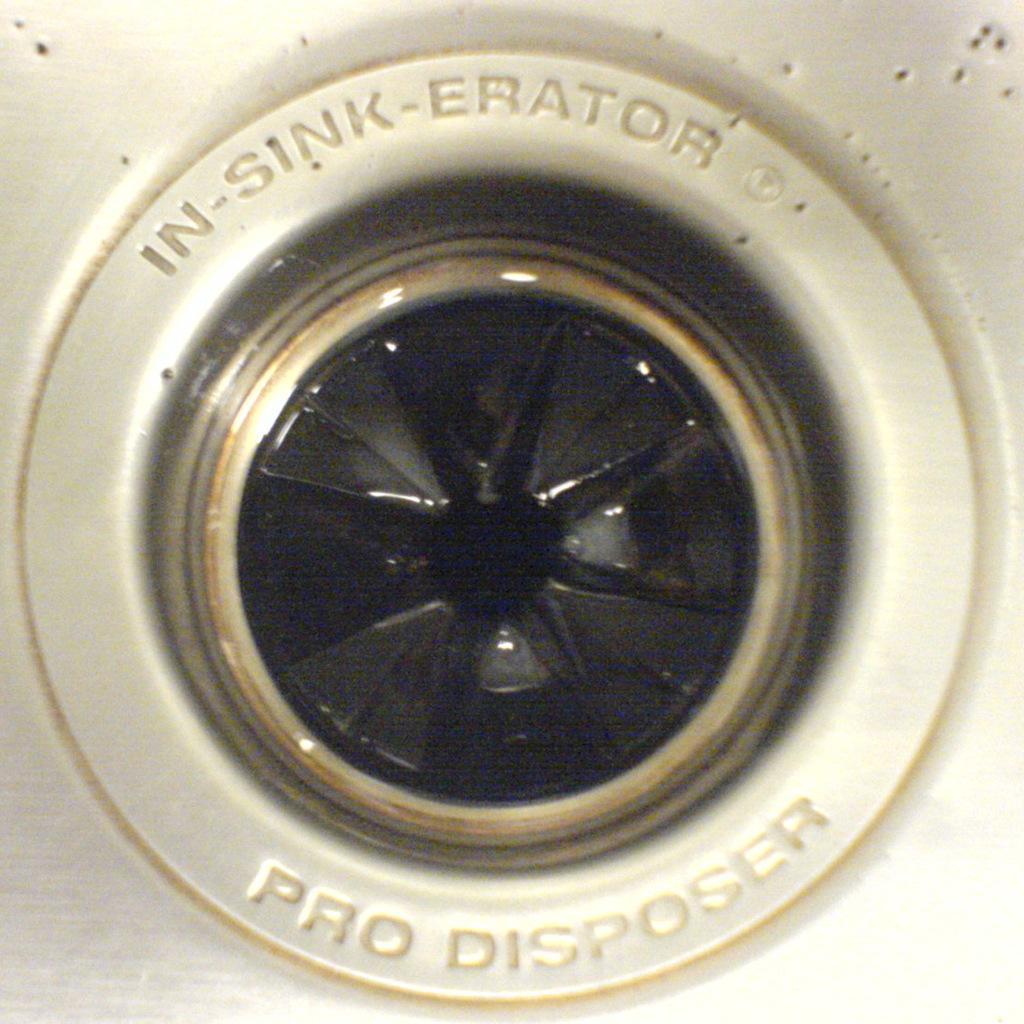Please provide a concise description of this image. In this image there is a garbage disposal and something is written on it. 